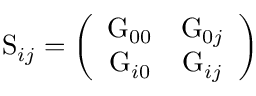<formula> <loc_0><loc_0><loc_500><loc_500>S _ { i j } = \left ( \begin{array} { c c } { { G _ { 0 0 } } } & { { G _ { 0 j } } } \\ { { G _ { i 0 } } } & { { G _ { i j } } } \end{array} \right )</formula> 